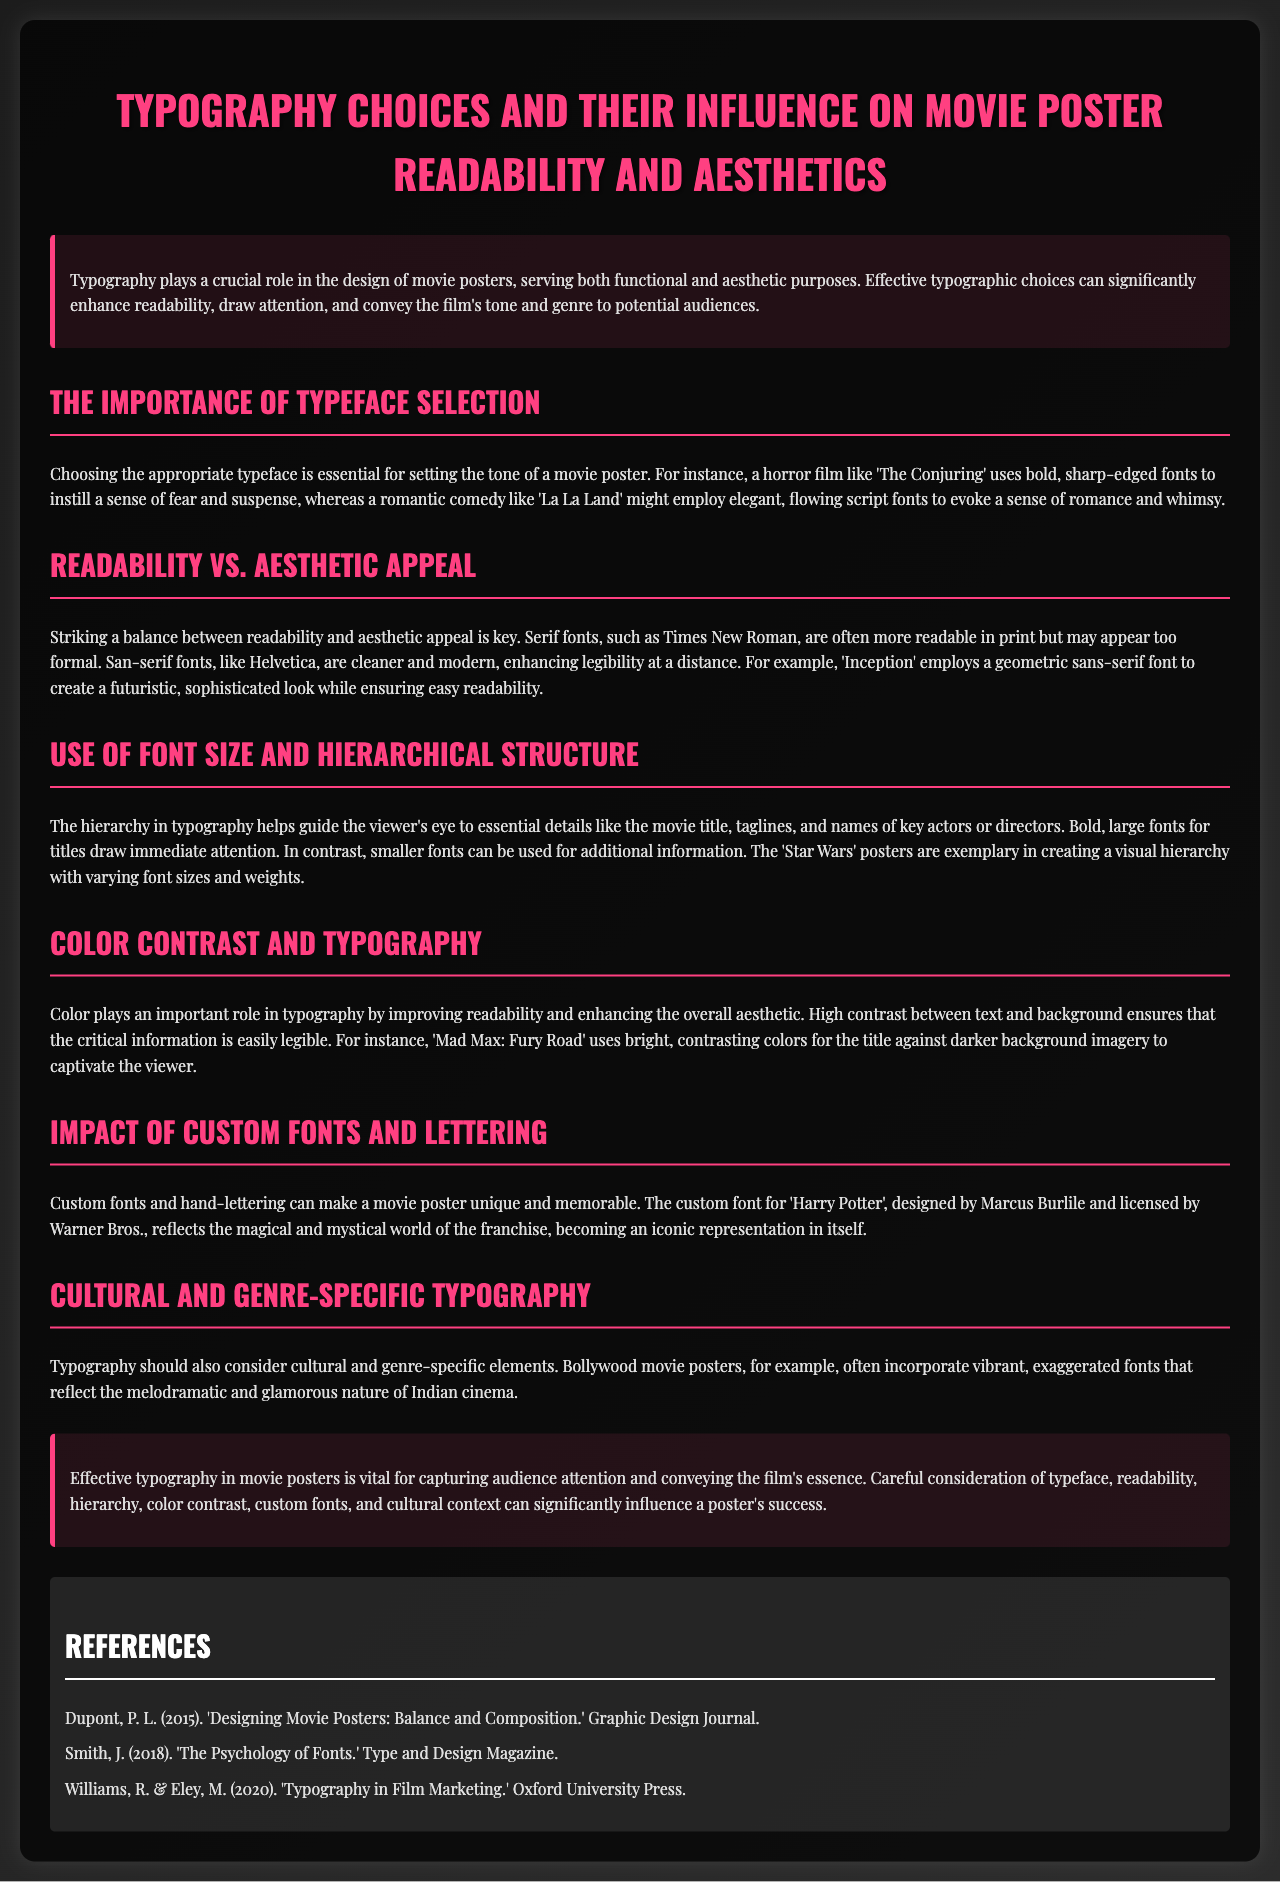What is the title of the lab report? The title of the lab report is explicitly stated as the first heading in the document.
Answer: Typography Choices and Their Influence on Movie Poster Readability and Aesthetics What font is used for headings in the document? The document specifies the font family used for headings in the CSS section provided.
Answer: Oswald What film is mentioned as using bold, sharp-edged fonts? The document includes examples of films illustrating typographic choices and mentions a specific horror film.
Answer: The Conjuring Which film is cited as employing a geometric sans-serif font? The report provides an example of a film and its font choice to demonstrate typography effects on aesthetics.
Answer: Inception What effect does high contrast in typography have? A specific section describes the role of color in typography concerning readability and aesthetic improvement.
Answer: Improves readability Who designed the custom font for 'Harry Potter'? The document states the designer of the custom font used for this iconic film franchise.
Answer: Marcus Burlile What type of fonts are often more readable in print? The lab report discusses the readability of different font types, particularly in relation to print medium.
Answer: Serif fonts What is one characteristic of Bollywood movie poster typography? The document highlights distinctive qualities in a particular cultural context regarding typography.
Answer: Vibrant and exaggerated fonts How is the section on color contrast labeled in the document? Each section has a heading indicating its theme, one of which is related to the impact of color in typography.
Answer: Color Contrast and Typography 